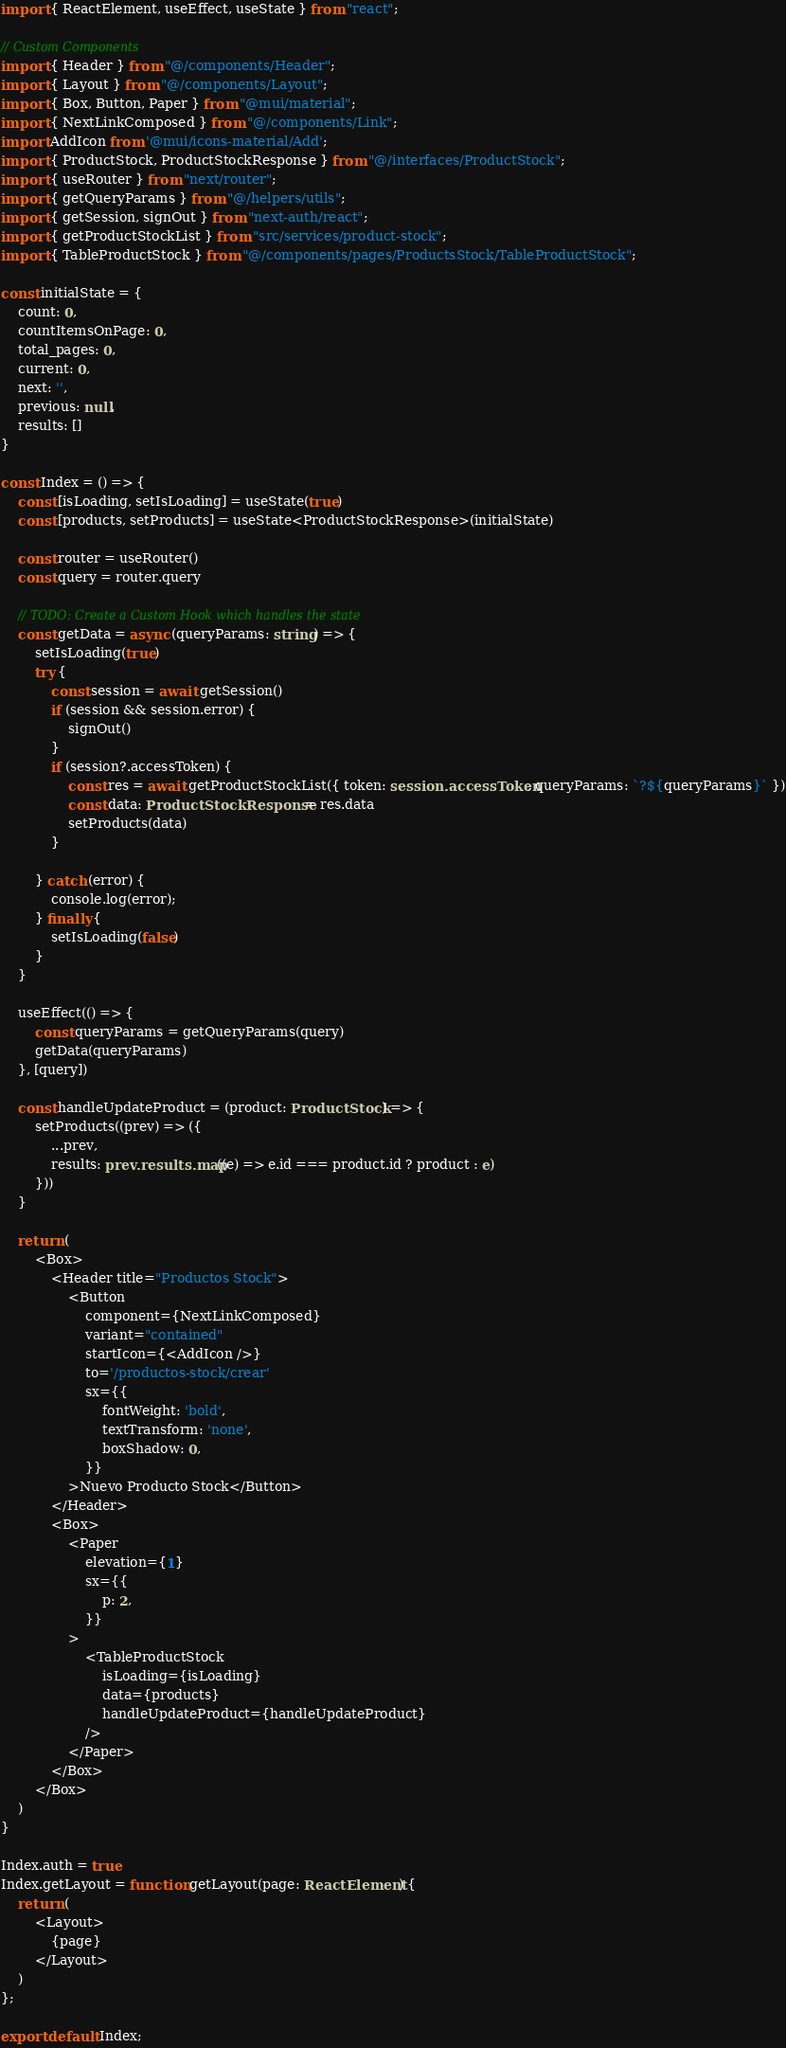<code> <loc_0><loc_0><loc_500><loc_500><_TypeScript_>import { ReactElement, useEffect, useState } from "react";

// Custom Components
import { Header } from "@/components/Header";
import { Layout } from "@/components/Layout";
import { Box, Button, Paper } from "@mui/material";
import { NextLinkComposed } from "@/components/Link";
import AddIcon from '@mui/icons-material/Add';
import { ProductStock, ProductStockResponse } from "@/interfaces/ProductStock";
import { useRouter } from "next/router";
import { getQueryParams } from "@/helpers/utils";
import { getSession, signOut } from "next-auth/react";
import { getProductStockList } from "src/services/product-stock";
import { TableProductStock } from "@/components/pages/ProductsStock/TableProductStock";

const initialState = {
	count: 0,
	countItemsOnPage: 0,
	total_pages: 0,
	current: 0,
	next: '',
	previous: null,
	results: []
}

const Index = () => {
	const [isLoading, setIsLoading] = useState(true)
	const [products, setProducts] = useState<ProductStockResponse>(initialState)

	const router = useRouter()
	const query = router.query

	// TODO: Create a Custom Hook which handles the state
	const getData = async (queryParams: string) => {
		setIsLoading(true)
		try {
			const session = await getSession()
			if (session && session.error) {
				signOut()
			}
			if (session?.accessToken) {
				const res = await getProductStockList({ token: session.accessToken, queryParams: `?${queryParams}` })
				const data: ProductStockResponse = res.data
				setProducts(data)
			}

		} catch (error) {
			console.log(error);
		} finally {
			setIsLoading(false)
		}
	}

	useEffect(() => {
		const queryParams = getQueryParams(query)
		getData(queryParams)
	}, [query])

	const handleUpdateProduct = (product: ProductStock) => {
		setProducts((prev) => ({
			...prev,
			results: prev.results.map((e) => e.id === product.id ? product : e)
		}))
	}

	return (
		<Box>
			<Header title="Productos Stock">
				<Button
					component={NextLinkComposed}
					variant="contained"
					startIcon={<AddIcon />}
					to='/productos-stock/crear'
					sx={{
						fontWeight: 'bold',
						textTransform: 'none',
						boxShadow: 0,
					}}
				>Nuevo Producto Stock</Button>
			</Header>
			<Box>
				<Paper
					elevation={1}
					sx={{
						p: 2,
					}}
				>
					<TableProductStock
						isLoading={isLoading}
						data={products}
						handleUpdateProduct={handleUpdateProduct}
					/>
				</Paper>
			</Box>
		</Box>
	)
}

Index.auth = true
Index.getLayout = function getLayout(page: ReactElement) {
	return (
		<Layout>
			{page}
		</Layout>
	)
};

export default Index;
</code> 